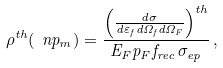Convert formula to latex. <formula><loc_0><loc_0><loc_500><loc_500>\rho ^ { t h } ( \ n p _ { m } ) = \frac { \left ( \frac { d \sigma } { d \varepsilon _ { f } d \Omega _ { f } d \Omega _ { F } } \right ) ^ { t h } } { E _ { F } p _ { F } f _ { r e c } \, \sigma _ { e p } } \, ,</formula> 